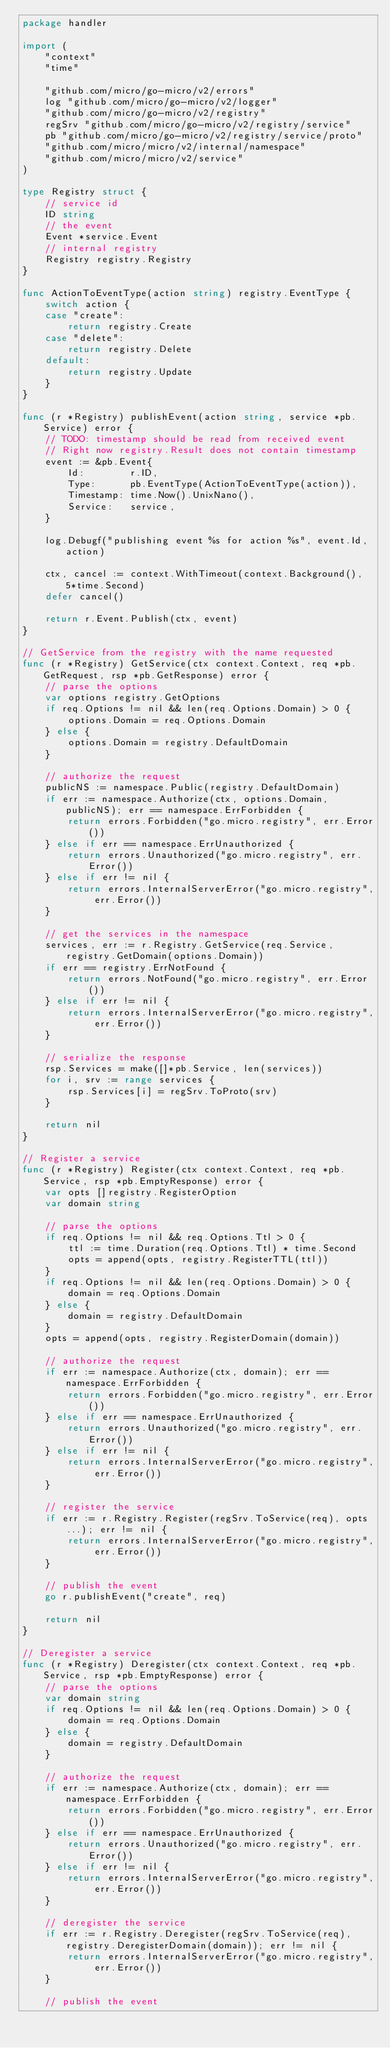Convert code to text. <code><loc_0><loc_0><loc_500><loc_500><_Go_>package handler

import (
	"context"
	"time"

	"github.com/micro/go-micro/v2/errors"
	log "github.com/micro/go-micro/v2/logger"
	"github.com/micro/go-micro/v2/registry"
	regSrv "github.com/micro/go-micro/v2/registry/service"
	pb "github.com/micro/go-micro/v2/registry/service/proto"
	"github.com/micro/micro/v2/internal/namespace"
	"github.com/micro/micro/v2/service"
)

type Registry struct {
	// service id
	ID string
	// the event
	Event *service.Event
	// internal registry
	Registry registry.Registry
}

func ActionToEventType(action string) registry.EventType {
	switch action {
	case "create":
		return registry.Create
	case "delete":
		return registry.Delete
	default:
		return registry.Update
	}
}

func (r *Registry) publishEvent(action string, service *pb.Service) error {
	// TODO: timestamp should be read from received event
	// Right now registry.Result does not contain timestamp
	event := &pb.Event{
		Id:        r.ID,
		Type:      pb.EventType(ActionToEventType(action)),
		Timestamp: time.Now().UnixNano(),
		Service:   service,
	}

	log.Debugf("publishing event %s for action %s", event.Id, action)

	ctx, cancel := context.WithTimeout(context.Background(), 5*time.Second)
	defer cancel()

	return r.Event.Publish(ctx, event)
}

// GetService from the registry with the name requested
func (r *Registry) GetService(ctx context.Context, req *pb.GetRequest, rsp *pb.GetResponse) error {
	// parse the options
	var options registry.GetOptions
	if req.Options != nil && len(req.Options.Domain) > 0 {
		options.Domain = req.Options.Domain
	} else {
		options.Domain = registry.DefaultDomain
	}

	// authorize the request
	publicNS := namespace.Public(registry.DefaultDomain)
	if err := namespace.Authorize(ctx, options.Domain, publicNS); err == namespace.ErrForbidden {
		return errors.Forbidden("go.micro.registry", err.Error())
	} else if err == namespace.ErrUnauthorized {
		return errors.Unauthorized("go.micro.registry", err.Error())
	} else if err != nil {
		return errors.InternalServerError("go.micro.registry", err.Error())
	}

	// get the services in the namespace
	services, err := r.Registry.GetService(req.Service, registry.GetDomain(options.Domain))
	if err == registry.ErrNotFound {
		return errors.NotFound("go.micro.registry", err.Error())
	} else if err != nil {
		return errors.InternalServerError("go.micro.registry", err.Error())
	}

	// serialize the response
	rsp.Services = make([]*pb.Service, len(services))
	for i, srv := range services {
		rsp.Services[i] = regSrv.ToProto(srv)
	}

	return nil
}

// Register a service
func (r *Registry) Register(ctx context.Context, req *pb.Service, rsp *pb.EmptyResponse) error {
	var opts []registry.RegisterOption
	var domain string

	// parse the options
	if req.Options != nil && req.Options.Ttl > 0 {
		ttl := time.Duration(req.Options.Ttl) * time.Second
		opts = append(opts, registry.RegisterTTL(ttl))
	}
	if req.Options != nil && len(req.Options.Domain) > 0 {
		domain = req.Options.Domain
	} else {
		domain = registry.DefaultDomain
	}
	opts = append(opts, registry.RegisterDomain(domain))

	// authorize the request
	if err := namespace.Authorize(ctx, domain); err == namespace.ErrForbidden {
		return errors.Forbidden("go.micro.registry", err.Error())
	} else if err == namespace.ErrUnauthorized {
		return errors.Unauthorized("go.micro.registry", err.Error())
	} else if err != nil {
		return errors.InternalServerError("go.micro.registry", err.Error())
	}

	// register the service
	if err := r.Registry.Register(regSrv.ToService(req), opts...); err != nil {
		return errors.InternalServerError("go.micro.registry", err.Error())
	}

	// publish the event
	go r.publishEvent("create", req)

	return nil
}

// Deregister a service
func (r *Registry) Deregister(ctx context.Context, req *pb.Service, rsp *pb.EmptyResponse) error {
	// parse the options
	var domain string
	if req.Options != nil && len(req.Options.Domain) > 0 {
		domain = req.Options.Domain
	} else {
		domain = registry.DefaultDomain
	}

	// authorize the request
	if err := namespace.Authorize(ctx, domain); err == namespace.ErrForbidden {
		return errors.Forbidden("go.micro.registry", err.Error())
	} else if err == namespace.ErrUnauthorized {
		return errors.Unauthorized("go.micro.registry", err.Error())
	} else if err != nil {
		return errors.InternalServerError("go.micro.registry", err.Error())
	}

	// deregister the service
	if err := r.Registry.Deregister(regSrv.ToService(req), registry.DeregisterDomain(domain)); err != nil {
		return errors.InternalServerError("go.micro.registry", err.Error())
	}

	// publish the event</code> 